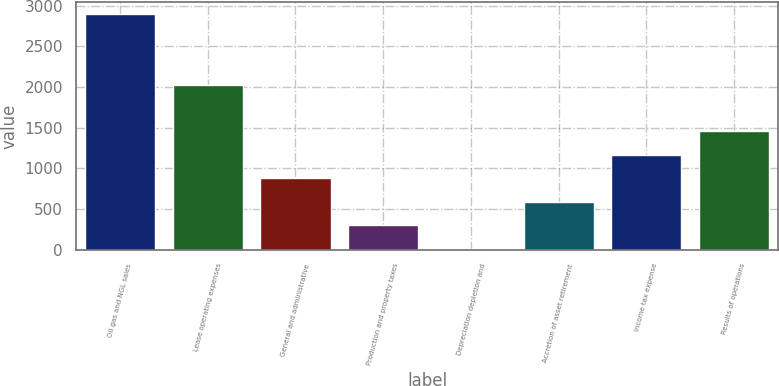Convert chart to OTSL. <chart><loc_0><loc_0><loc_500><loc_500><bar_chart><fcel>Oil gas and NGL sales<fcel>Lease operating expenses<fcel>General and administrative<fcel>Production and property taxes<fcel>Depreciation depletion and<fcel>Accretion of asset retirement<fcel>Income tax expense<fcel>Results of operations<nl><fcel>2897<fcel>2031.45<fcel>877.33<fcel>300.27<fcel>11.74<fcel>588.8<fcel>1165.86<fcel>1454.39<nl></chart> 